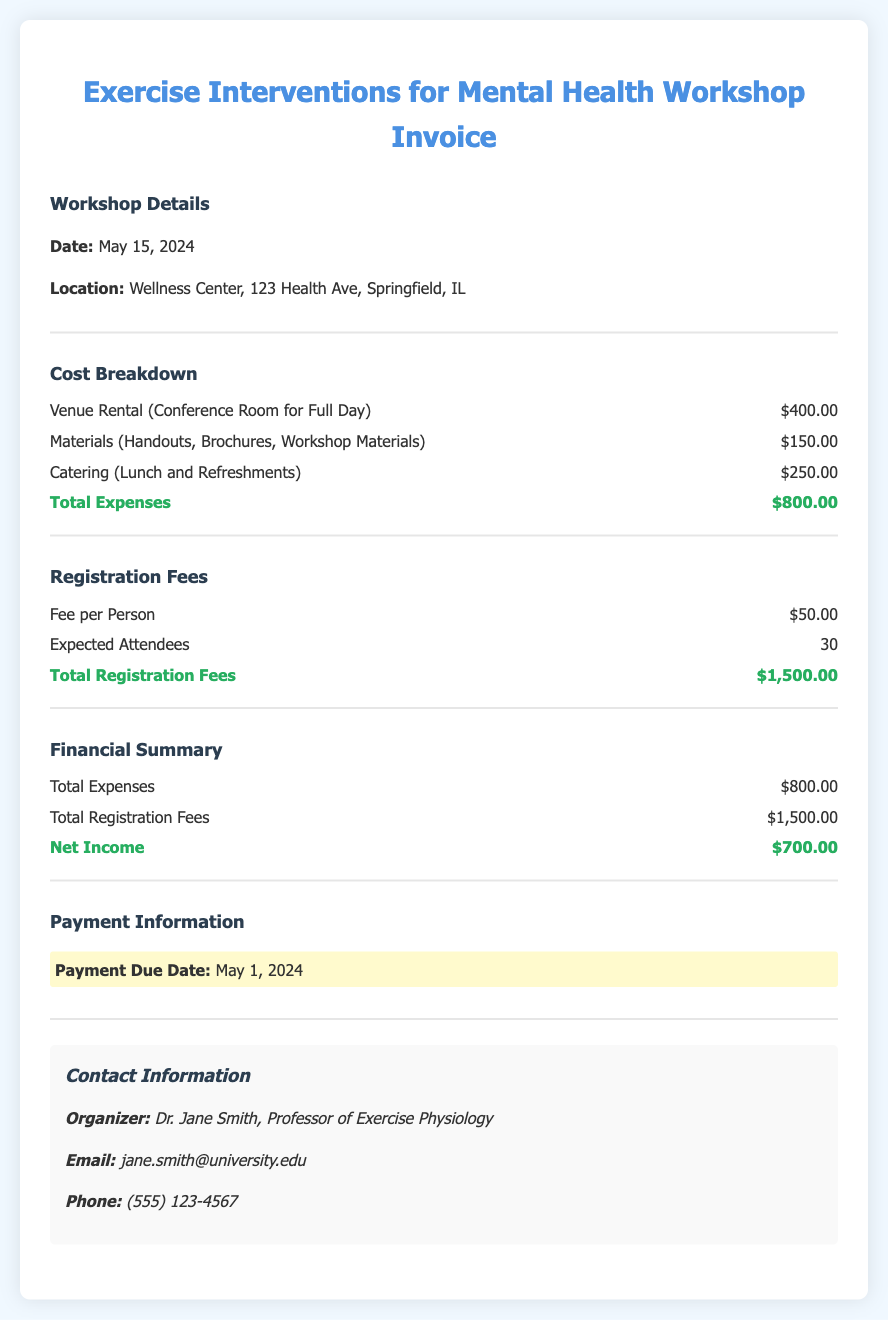what date is the workshop scheduled? The document states that the workshop is scheduled for May 15, 2024.
Answer: May 15, 2024 what is the total expense for the venue rental? The document lists the venue rental cost as $400.00.
Answer: $400.00 how many expected attendees are there for the workshop? The expected number of attendees is specified as 30 in the document.
Answer: 30 what is the payment due date? According to the document, the payment due date is May 1, 2024.
Answer: May 1, 2024 what is the total registration fee amount? The total registration fees are calculated as $1,500.00 in the document.
Answer: $1,500.00 what is the total net income from the workshop? The document shows that the net income is $700.00 after deducting expenses from registration fees.
Answer: $700.00 who is the organizer of the workshop? The organizer is Dr. Jane Smith as stated in the contact information section.
Answer: Dr. Jane Smith what are the workshop materials costs? The costs for materials are listed as $150.00 in the cost breakdown.
Answer: $150.00 how much is the fee per person for registration? The document states that the fee per person is $50.00.
Answer: $50.00 